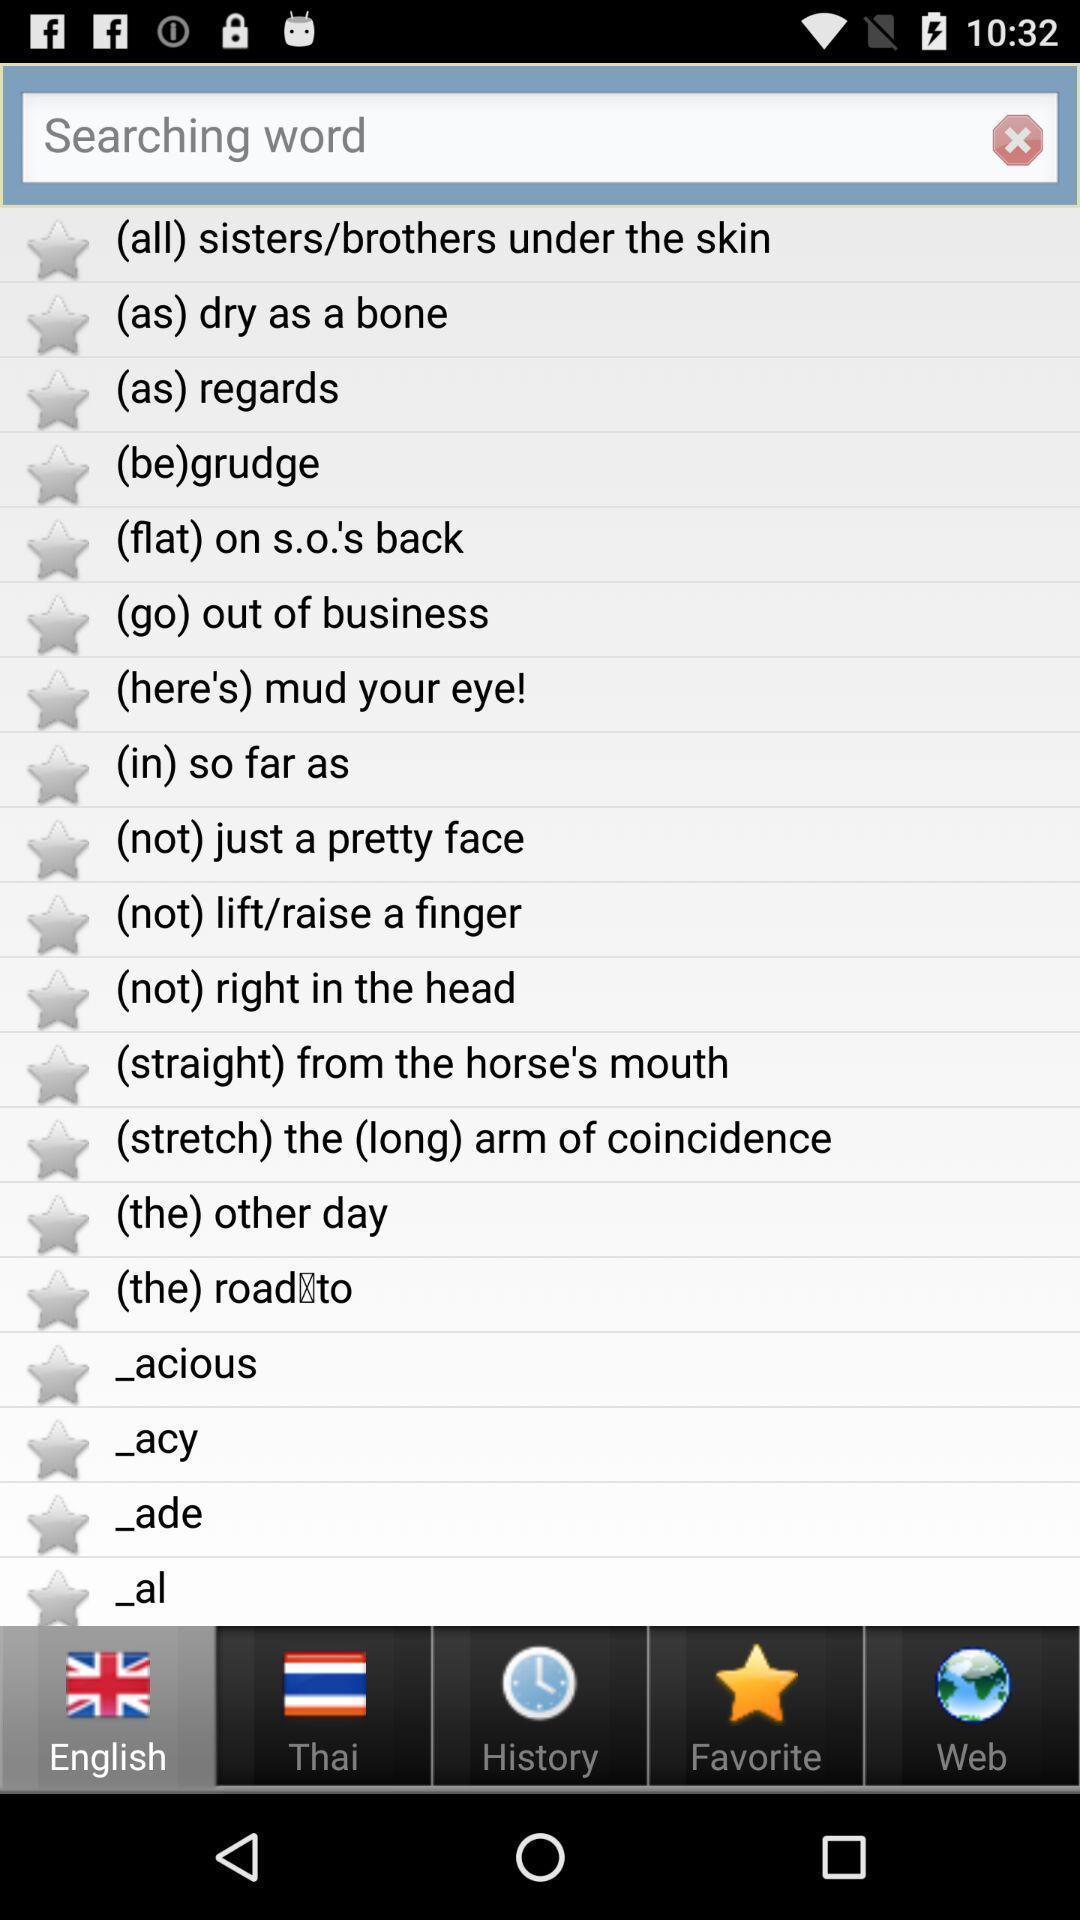Provide a textual representation of this image. Search page with list in the dictionary app. 